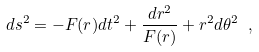<formula> <loc_0><loc_0><loc_500><loc_500>d s ^ { 2 } = - F ( r ) d t ^ { 2 } + \frac { d r ^ { 2 } } { F ( r ) } + r ^ { 2 } d \theta ^ { 2 } \ ,</formula> 